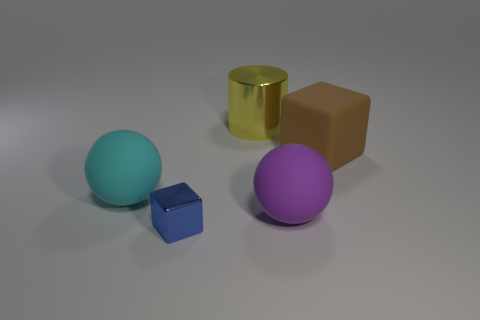Is the number of green rubber blocks less than the number of big cyan rubber objects? Yes, there are no green rubber blocks present, hence their number is less than that of any other objects, including the big cyan one which is visible in the image. 